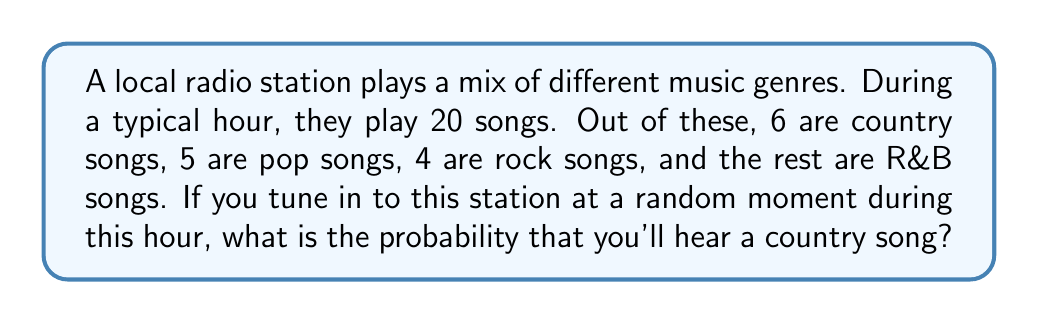What is the answer to this math problem? Let's approach this step-by-step:

1) First, we need to determine the total number of songs played in an hour:
   $$ \text{Total songs} = 6 + 5 + 4 + (\text{R&B songs}) = 20 $$

2) We can calculate the number of R&B songs:
   $$ \text{R&B songs} = 20 - (6 + 5 + 4) = 5 $$

3) Now, to calculate the probability, we assume that each song has an equal duration. The probability of hearing a country song is equal to the fraction of country songs in the total playlist:

   $$ P(\text{country song}) = \frac{\text{Number of country songs}}{\text{Total number of songs}} $$

4) Substituting the values:

   $$ P(\text{country song}) = \frac{6}{20} = \frac{3}{10} = 0.3 $$

5) We can express this as a percentage:

   $$ 0.3 \times 100\% = 30\% $$

Therefore, there is a 30% chance of hearing a country song when you tune in to this station at a random moment during the hour.
Answer: $\frac{3}{10}$ or $0.3$ or $30\%$ 